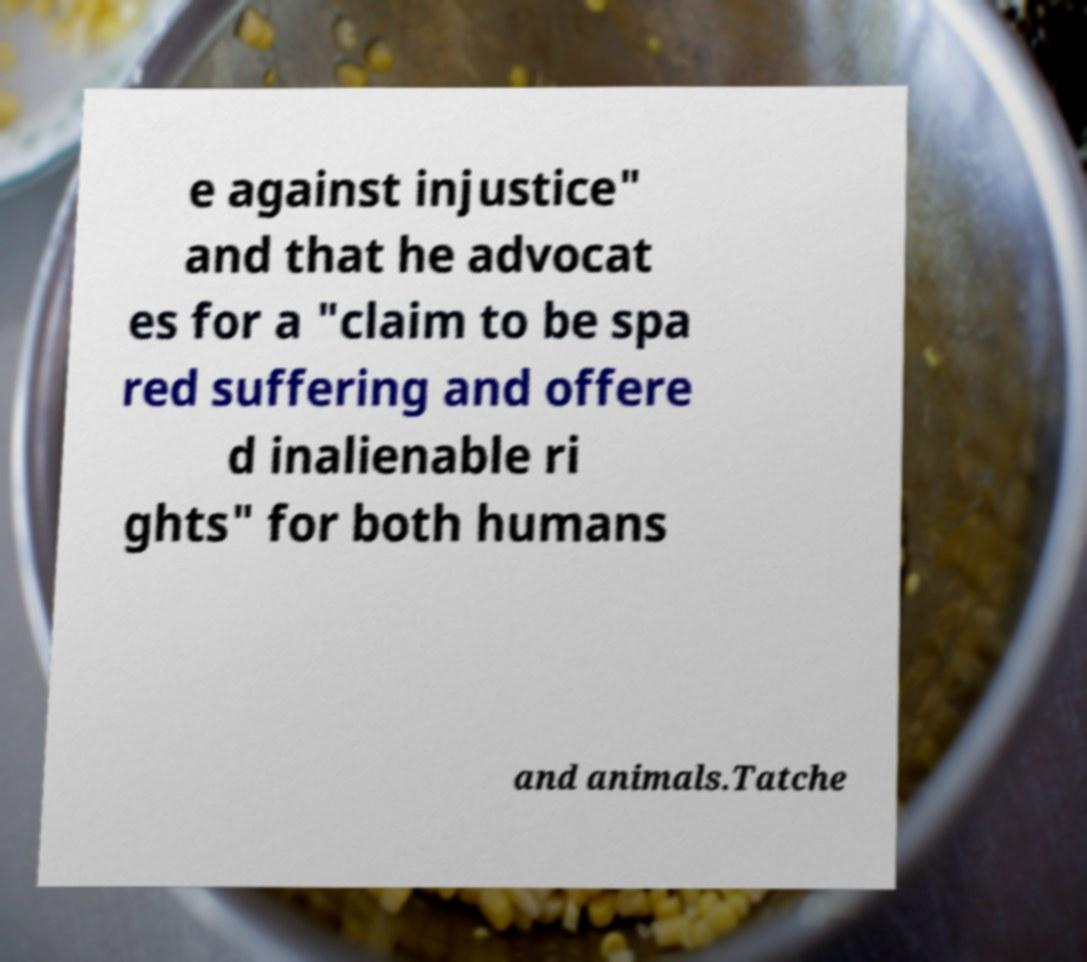Could you extract and type out the text from this image? e against injustice" and that he advocat es for a "claim to be spa red suffering and offere d inalienable ri ghts" for both humans and animals.Tatche 